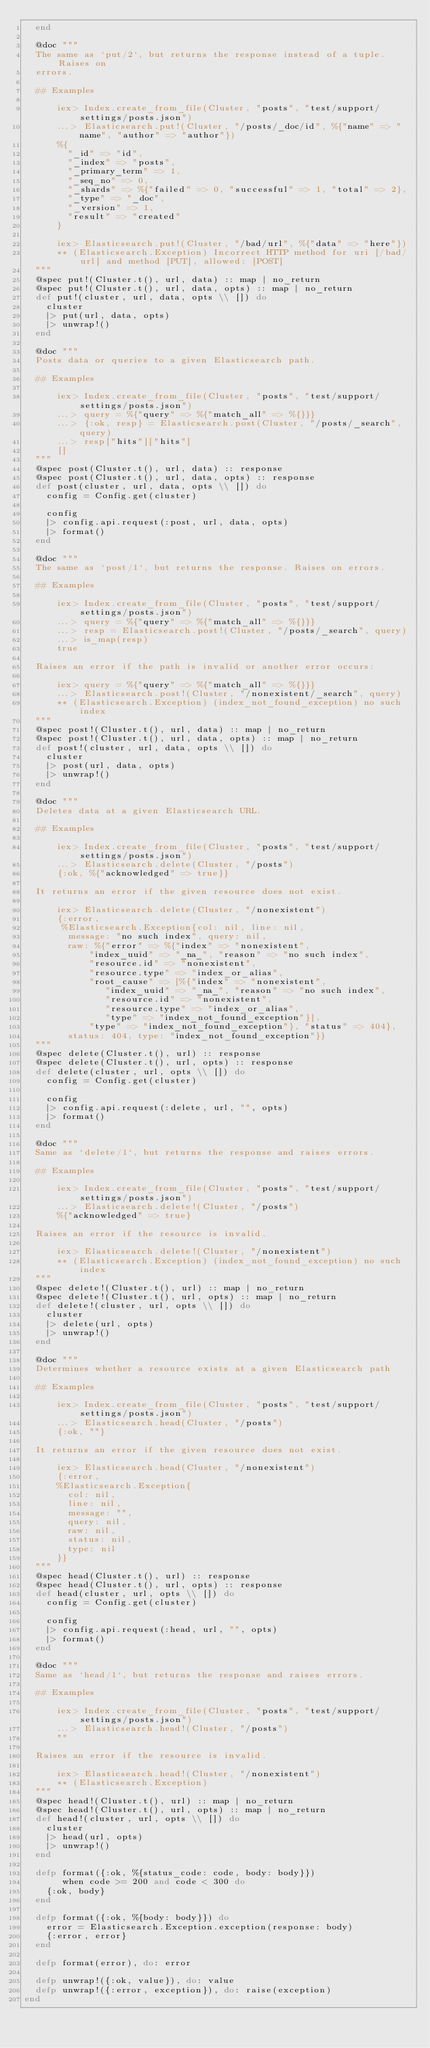<code> <loc_0><loc_0><loc_500><loc_500><_Elixir_>  end

  @doc """
  The same as `put/2`, but returns the response instead of a tuple. Raises on
  errors.

  ## Examples

      iex> Index.create_from_file(Cluster, "posts", "test/support/settings/posts.json")
      ...> Elasticsearch.put!(Cluster, "/posts/_doc/id", %{"name" => "name", "author" => "author"})
      %{
        "_id" => "id",
        "_index" => "posts",
        "_primary_term" => 1,
        "_seq_no" => 0,
        "_shards" => %{"failed" => 0, "successful" => 1, "total" => 2},
        "_type" => "_doc",
        "_version" => 1,
        "result" => "created"
      }

      iex> Elasticsearch.put!(Cluster, "/bad/url", %{"data" => "here"})
      ** (Elasticsearch.Exception) Incorrect HTTP method for uri [/bad/url] and method [PUT], allowed: [POST]
  """
  @spec put!(Cluster.t(), url, data) :: map | no_return
  @spec put!(Cluster.t(), url, data, opts) :: map | no_return
  def put!(cluster, url, data, opts \\ []) do
    cluster
    |> put(url, data, opts)
    |> unwrap!()
  end

  @doc """
  Posts data or queries to a given Elasticsearch path.

  ## Examples

      iex> Index.create_from_file(Cluster, "posts", "test/support/settings/posts.json")
      ...> query = %{"query" => %{"match_all" => %{}}}
      ...> {:ok, resp} = Elasticsearch.post(Cluster, "/posts/_search", query)
      ...> resp["hits"]["hits"]
      []
  """
  @spec post(Cluster.t(), url, data) :: response
  @spec post(Cluster.t(), url, data, opts) :: response
  def post(cluster, url, data, opts \\ []) do
    config = Config.get(cluster)

    config
    |> config.api.request(:post, url, data, opts)
    |> format()
  end

  @doc """
  The same as `post/1`, but returns the response. Raises on errors.

  ## Examples

      iex> Index.create_from_file(Cluster, "posts", "test/support/settings/posts.json")
      ...> query = %{"query" => %{"match_all" => %{}}}
      ...> resp = Elasticsearch.post!(Cluster, "/posts/_search", query)
      ...> is_map(resp)
      true

  Raises an error if the path is invalid or another error occurs:

      iex> query = %{"query" => %{"match_all" => %{}}}
      ...> Elasticsearch.post!(Cluster, "/nonexistent/_search", query)
      ** (Elasticsearch.Exception) (index_not_found_exception) no such index
  """
  @spec post!(Cluster.t(), url, data) :: map | no_return
  @spec post!(Cluster.t(), url, data, opts) :: map | no_return
  def post!(cluster, url, data, opts \\ []) do
    cluster
    |> post(url, data, opts)
    |> unwrap!()
  end

  @doc """
  Deletes data at a given Elasticsearch URL.

  ## Examples

      iex> Index.create_from_file(Cluster, "posts", "test/support/settings/posts.json")
      ...> Elasticsearch.delete(Cluster, "/posts")
      {:ok, %{"acknowledged" => true}}

  It returns an error if the given resource does not exist.

      iex> Elasticsearch.delete(Cluster, "/nonexistent")
      {:error,
       %Elasticsearch.Exception{col: nil, line: nil,
        message: "no such index", query: nil,
        raw: %{"error" => %{"index" => "nonexistent",
            "index_uuid" => "_na_", "reason" => "no such index",
            "resource.id" => "nonexistent",
            "resource.type" => "index_or_alias",
            "root_cause" => [%{"index" => "nonexistent",
               "index_uuid" => "_na_", "reason" => "no such index",
               "resource.id" => "nonexistent",
               "resource.type" => "index_or_alias",
               "type" => "index_not_found_exception"}],
            "type" => "index_not_found_exception"}, "status" => 404},
        status: 404, type: "index_not_found_exception"}}
  """
  @spec delete(Cluster.t(), url) :: response
  @spec delete(Cluster.t(), url, opts) :: response
  def delete(cluster, url, opts \\ []) do
    config = Config.get(cluster)

    config
    |> config.api.request(:delete, url, "", opts)
    |> format()
  end

  @doc """
  Same as `delete/1`, but returns the response and raises errors.

  ## Examples

      iex> Index.create_from_file(Cluster, "posts", "test/support/settings/posts.json")
      ...> Elasticsearch.delete!(Cluster, "/posts")
      %{"acknowledged" => true}

  Raises an error if the resource is invalid.

      iex> Elasticsearch.delete!(Cluster, "/nonexistent")
      ** (Elasticsearch.Exception) (index_not_found_exception) no such index
  """
  @spec delete!(Cluster.t(), url) :: map | no_return
  @spec delete!(Cluster.t(), url, opts) :: map | no_return
  def delete!(cluster, url, opts \\ []) do
    cluster
    |> delete(url, opts)
    |> unwrap!()
  end

  @doc """
  Determines whether a resource exists at a given Elasticsearch path

  ## Examples

      iex> Index.create_from_file(Cluster, "posts", "test/support/settings/posts.json")
      ...> Elasticsearch.head(Cluster, "/posts")
      {:ok, ""}

  It returns an error if the given resource does not exist.

      iex> Elasticsearch.head(Cluster, "/nonexistent")
      {:error,
      %Elasticsearch.Exception{
        col: nil,
        line: nil,
        message: "",
        query: nil,
        raw: nil,
        status: nil,
        type: nil
      }}
  """
  @spec head(Cluster.t(), url) :: response
  @spec head(Cluster.t(), url, opts) :: response
  def head(cluster, url, opts \\ []) do
    config = Config.get(cluster)

    config
    |> config.api.request(:head, url, "", opts)
    |> format()
  end

  @doc """
  Same as `head/1`, but returns the response and raises errors.

  ## Examples

      iex> Index.create_from_file(Cluster, "posts", "test/support/settings/posts.json")
      ...> Elasticsearch.head!(Cluster, "/posts")
      ""

  Raises an error if the resource is invalid.

      iex> Elasticsearch.head!(Cluster, "/nonexistent")
      ** (Elasticsearch.Exception)
  """
  @spec head!(Cluster.t(), url) :: map | no_return
  @spec head!(Cluster.t(), url, opts) :: map | no_return
  def head!(cluster, url, opts \\ []) do
    cluster
    |> head(url, opts)
    |> unwrap!()
  end

  defp format({:ok, %{status_code: code, body: body}})
       when code >= 200 and code < 300 do
    {:ok, body}
  end

  defp format({:ok, %{body: body}}) do
    error = Elasticsearch.Exception.exception(response: body)
    {:error, error}
  end

  defp format(error), do: error

  defp unwrap!({:ok, value}), do: value
  defp unwrap!({:error, exception}), do: raise(exception)
end
</code> 